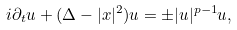<formula> <loc_0><loc_0><loc_500><loc_500>i \partial _ { t } u + ( \Delta - | x | ^ { 2 } ) u = \pm | u | ^ { p - 1 } u ,</formula> 